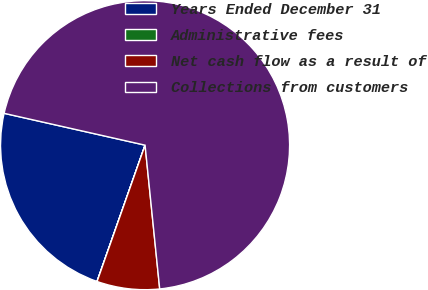Convert chart to OTSL. <chart><loc_0><loc_0><loc_500><loc_500><pie_chart><fcel>Years Ended December 31<fcel>Administrative fees<fcel>Net cash flow as a result of<fcel>Collections from customers<nl><fcel>23.14%<fcel>0.01%<fcel>7.0%<fcel>69.85%<nl></chart> 